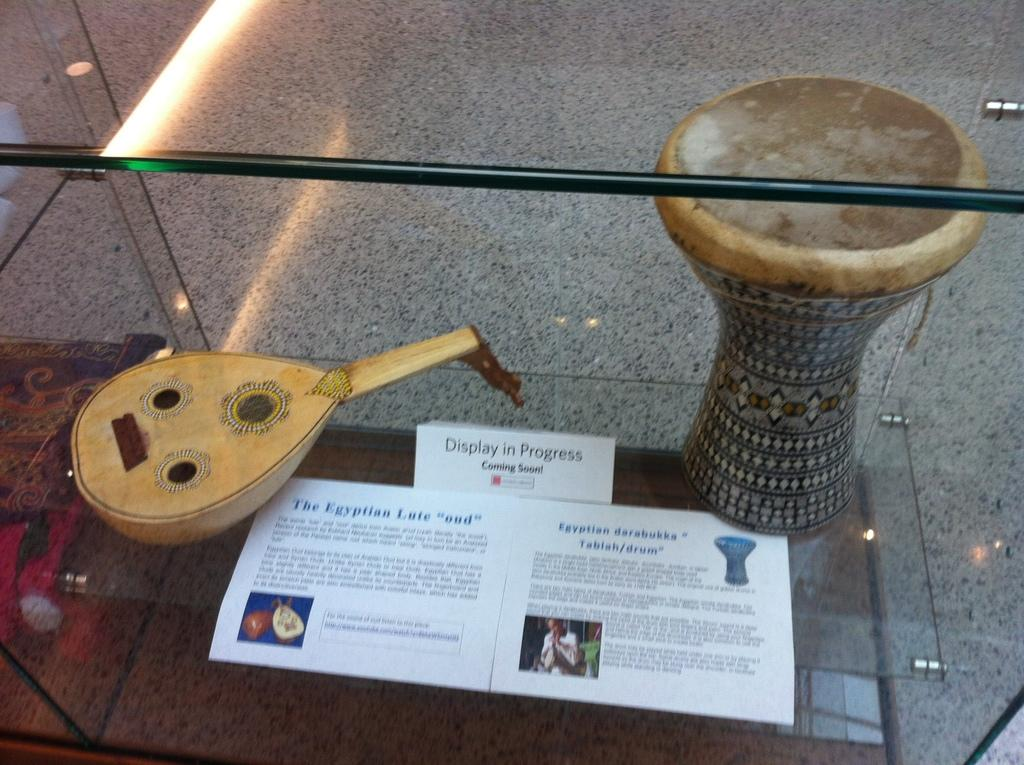What objects are present in the image related to music? There are musical instruments in the image. How are the musical instruments stored or displayed? The musical instruments are kept in a glass rack. Can you identify any other objects in the image related to identification or labeling? Yes, there is a name plate in the image. What type of writing material is visible in the image? There is a paper in the image. Is there a vase filled with flowers on the table in the image? There is no table or vase filled with flowers present in the image. 